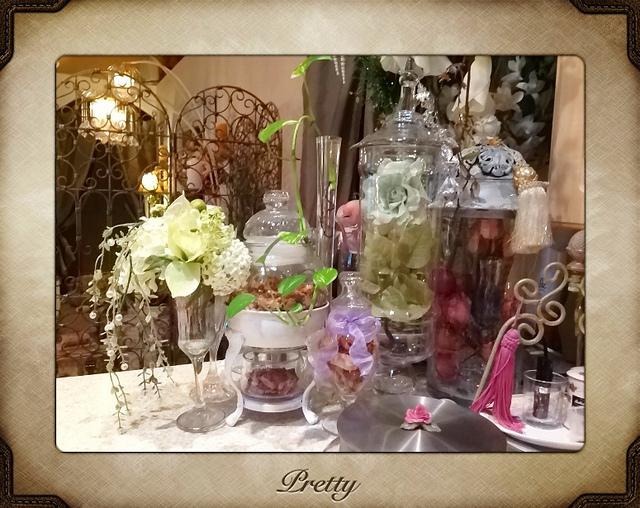What is the word at the bottom?
Answer briefly. Pretty. What color is the rose?
Be succinct. White. Are all the flowers in jars?
Give a very brief answer. Yes. 